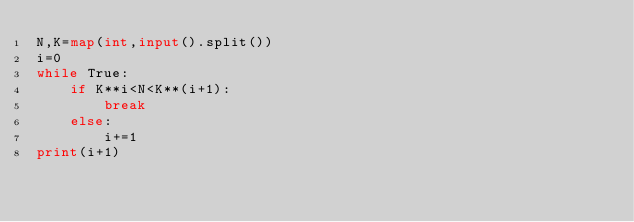Convert code to text. <code><loc_0><loc_0><loc_500><loc_500><_Python_>N,K=map(int,input().split())
i=0
while True:
    if K**i<N<K**(i+1):
        break
    else:
        i+=1
print(i+1)</code> 